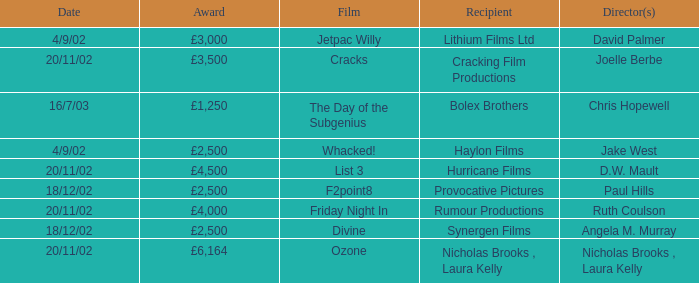Who directed a film for Cracking Film Productions? Joelle Berbe. 